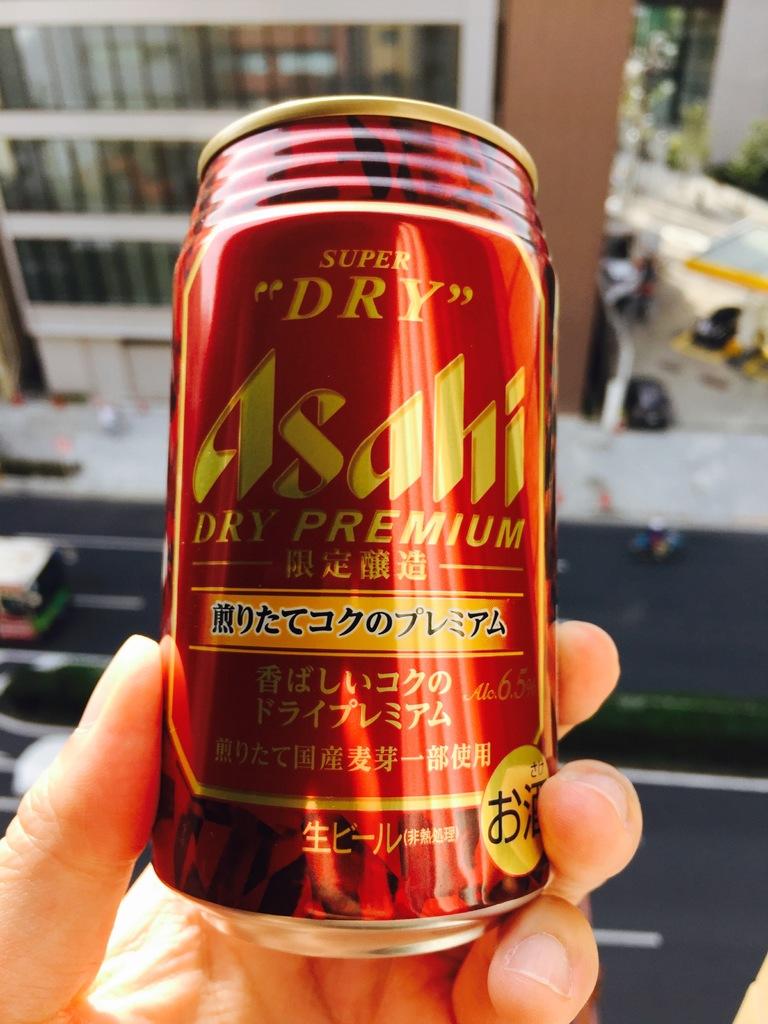What is super about this asahi premium beer?
Ensure brevity in your answer.  Dry. What brand is this?
Keep it short and to the point. Asahi. 